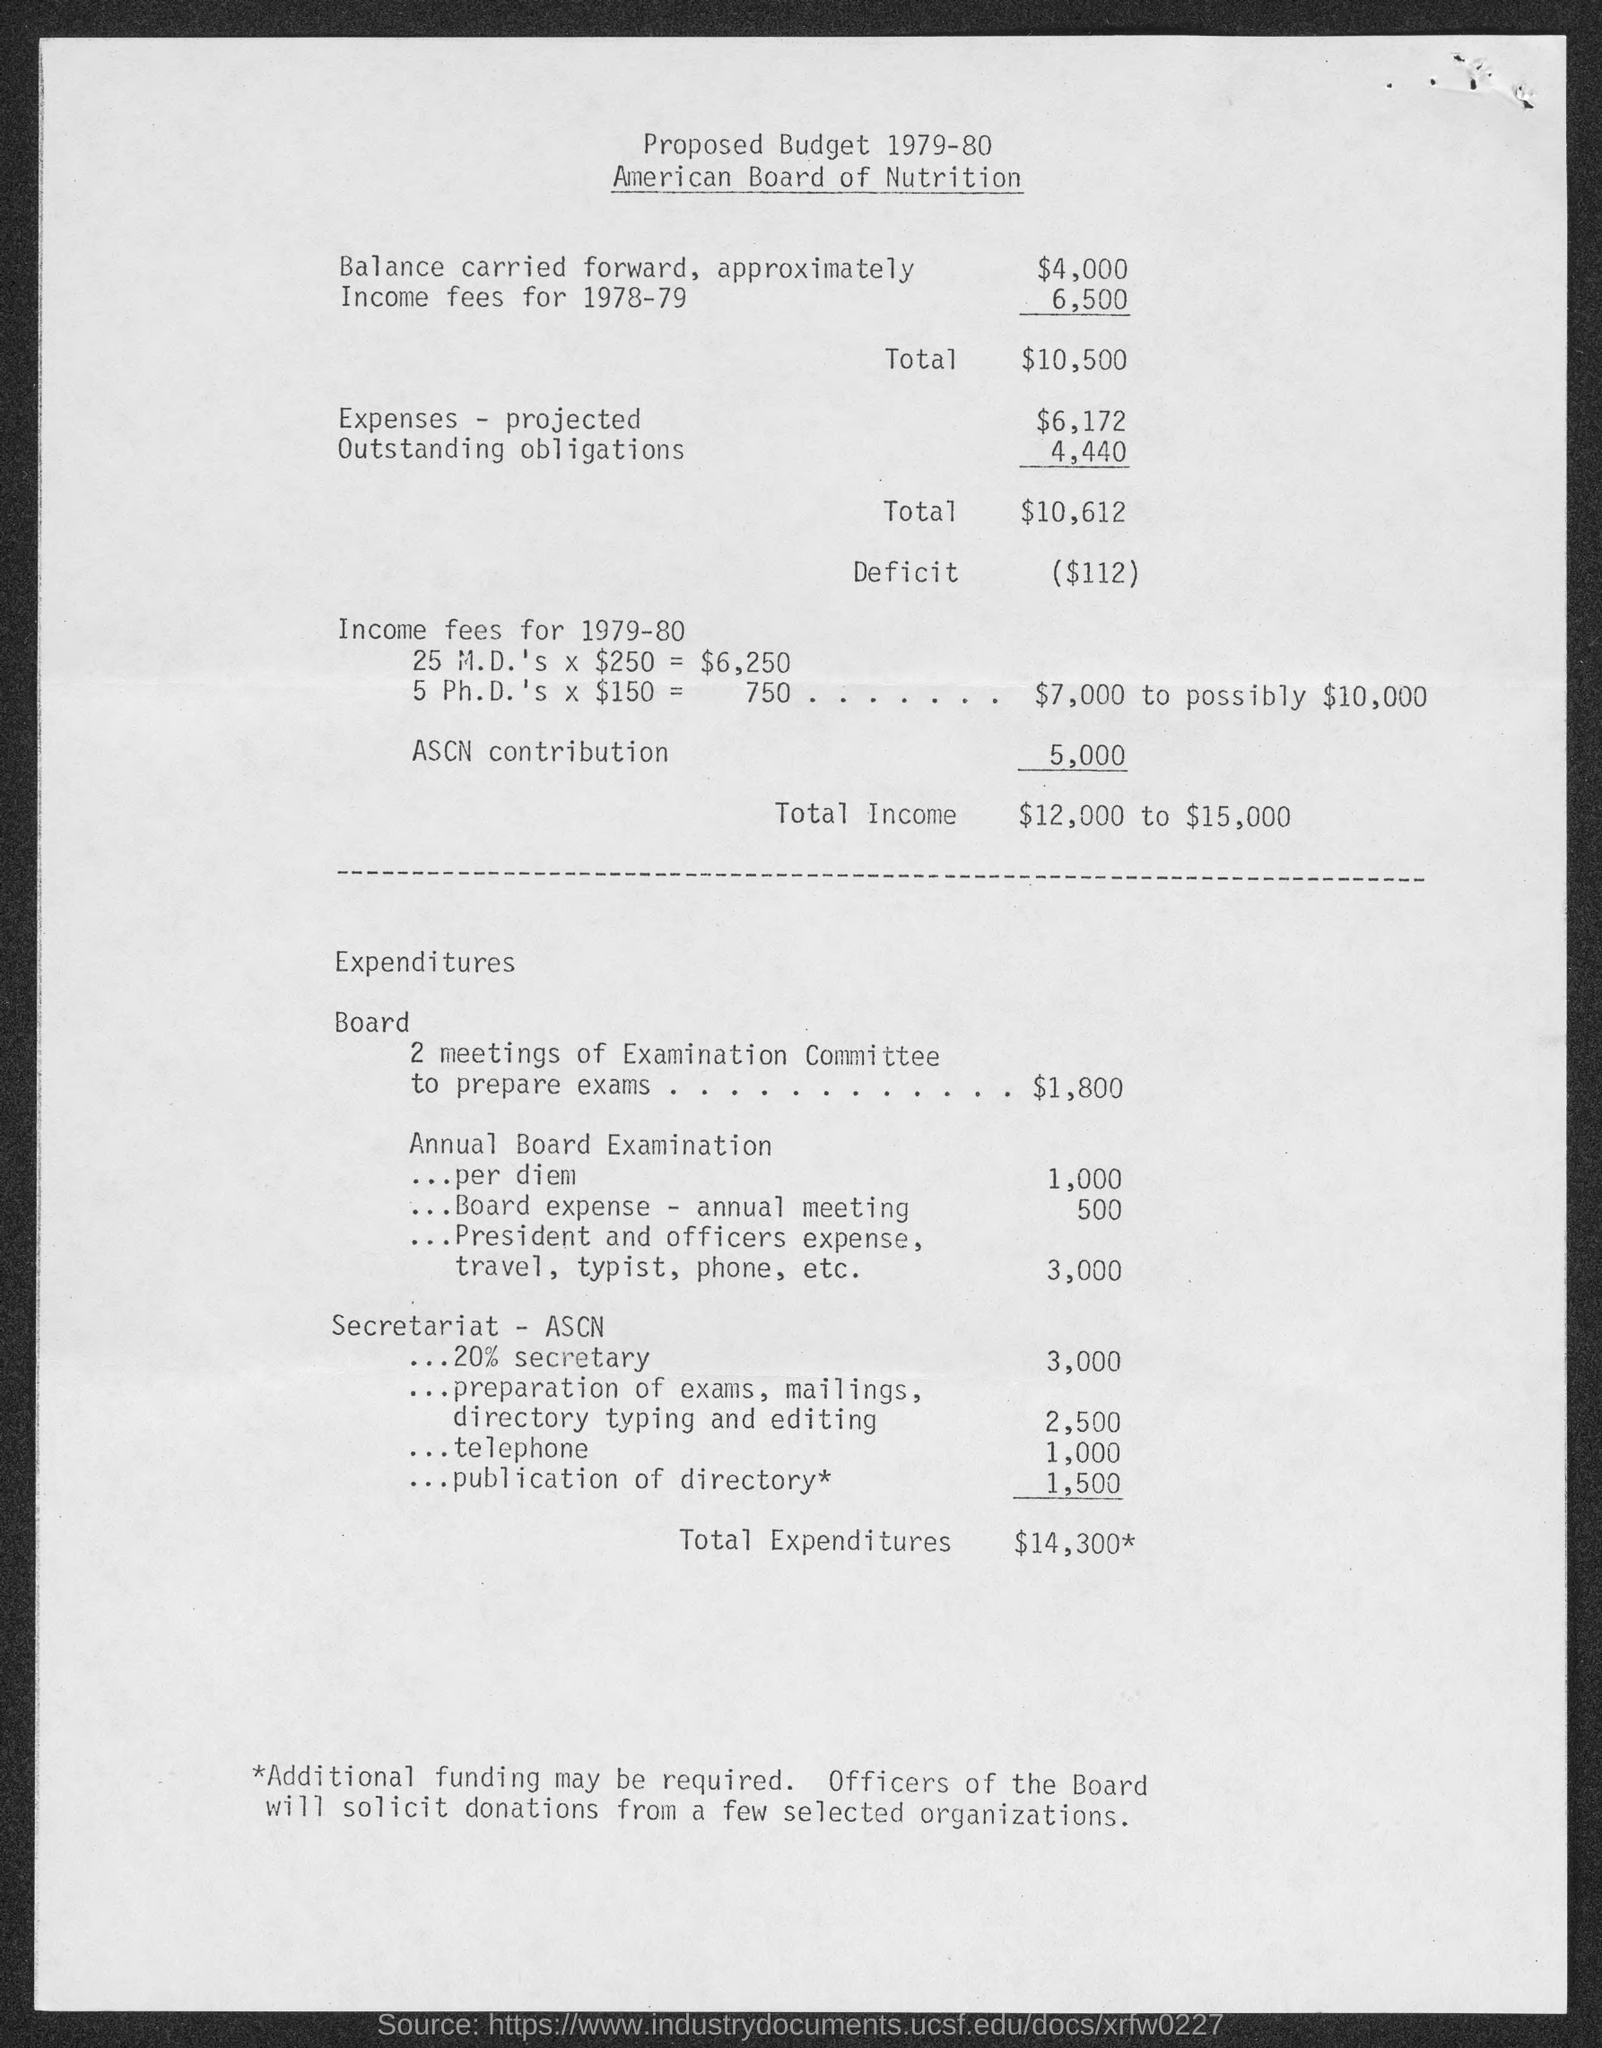What is the total income ?
Your answer should be very brief. $12,000 to $15,000. What is total expenditure?
Ensure brevity in your answer.  $14,300*. What is deficit amount?
Offer a very short reply. ($112). What is the balance carried forward approximately?
Offer a very short reply. 4,000. What is the amount of expenses- projected?
Make the answer very short. 6,172. 